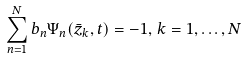Convert formula to latex. <formula><loc_0><loc_0><loc_500><loc_500>\sum _ { n = 1 } ^ { N } b _ { n } \Psi _ { n } ( \bar { z } _ { k } , t ) = - 1 , \, k = 1 , \dots , N</formula> 